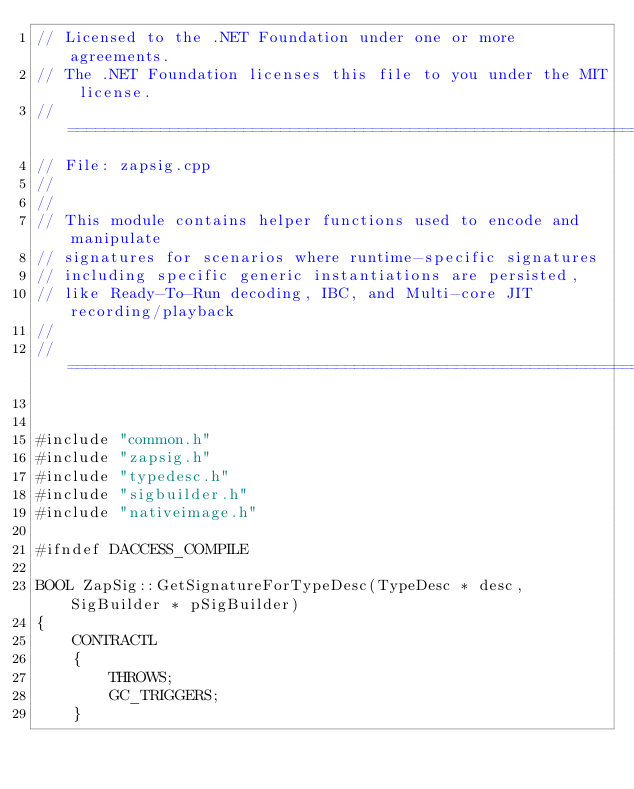<code> <loc_0><loc_0><loc_500><loc_500><_C++_>// Licensed to the .NET Foundation under one or more agreements.
// The .NET Foundation licenses this file to you under the MIT license.
// ===========================================================================
// File: zapsig.cpp
//
//
// This module contains helper functions used to encode and manipulate
// signatures for scenarios where runtime-specific signatures
// including specific generic instantiations are persisted,
// like Ready-To-Run decoding, IBC, and Multi-core JIT recording/playback
//
// ===========================================================================


#include "common.h"
#include "zapsig.h"
#include "typedesc.h"
#include "sigbuilder.h"
#include "nativeimage.h"

#ifndef DACCESS_COMPILE

BOOL ZapSig::GetSignatureForTypeDesc(TypeDesc * desc, SigBuilder * pSigBuilder)
{
    CONTRACTL
    {
        THROWS;
        GC_TRIGGERS;
    }</code> 